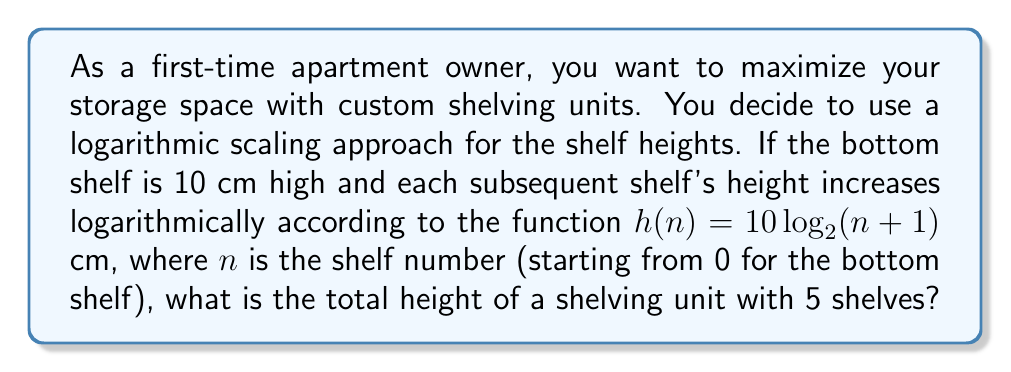What is the answer to this math problem? Let's approach this step-by-step:

1) We need to calculate the height of each shelf using the given function:
   $h(n) = 10 \log_2(n+1)$ cm

2) Calculate the height of each shelf:
   - Bottom shelf (n = 0): $h(0) = 10 \log_2(0+1) = 10 \log_2(1) = 10 \cdot 0 = 0$ cm
   - Second shelf (n = 1): $h(1) = 10 \log_2(1+1) = 10 \log_2(2) = 10 \cdot 1 = 10$ cm
   - Third shelf (n = 2): $h(2) = 10 \log_2(2+1) = 10 \log_2(3) \approx 15.85$ cm
   - Fourth shelf (n = 3): $h(3) = 10 log_2(3+1) = 10 \log_2(4) = 10 \cdot 2 = 20$ cm
   - Top shelf (n = 4): $h(4) = 10 \log_2(4+1) = 10 \log_2(5) \approx 23.22$ cm

3) To get the total height, we need to sum all these heights:
   Total height = 0 + 10 + 15.85 + 20 + 23.22 = 69.07 cm

Therefore, the total height of the shelving unit with 5 shelves is approximately 69.07 cm.
Answer: The total height of the shelving unit with 5 shelves is approximately 69.07 cm. 